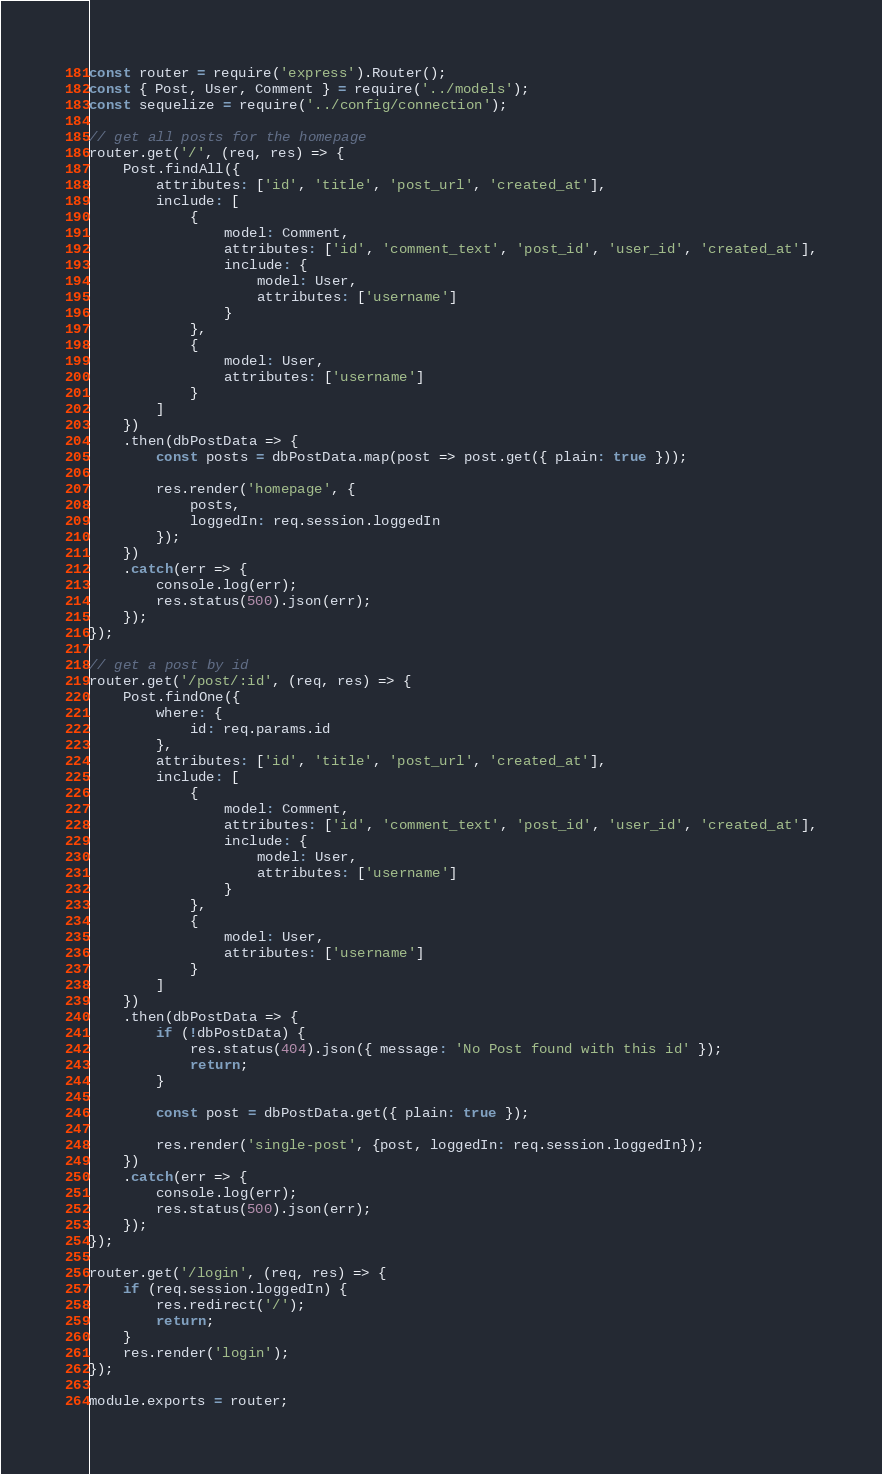<code> <loc_0><loc_0><loc_500><loc_500><_JavaScript_>const router = require('express').Router();
const { Post, User, Comment } = require('../models');
const sequelize = require('../config/connection');

// get all posts for the homepage
router.get('/', (req, res) => {
    Post.findAll({
        attributes: ['id', 'title', 'post_url', 'created_at'],
        include: [
            {
                model: Comment,
                attributes: ['id', 'comment_text', 'post_id', 'user_id', 'created_at'],
                include: {
                    model: User,
                    attributes: ['username']
                }
            },
            {
                model: User,
                attributes: ['username']
            }
        ]
    })
    .then(dbPostData => {
        const posts = dbPostData.map(post => post.get({ plain: true }));

        res.render('homepage', {
            posts,
            loggedIn: req.session.loggedIn
        });
    })
    .catch(err => {
        console.log(err);
        res.status(500).json(err);
    });
});

// get a post by id
router.get('/post/:id', (req, res) => {
    Post.findOne({
        where: {
            id: req.params.id
        },
        attributes: ['id', 'title', 'post_url', 'created_at'],
        include: [
            {
                model: Comment,
                attributes: ['id', 'comment_text', 'post_id', 'user_id', 'created_at'],
                include: {
                    model: User,
                    attributes: ['username']
                }
            },
            {
                model: User,
                attributes: ['username']
            }
        ]
    })
    .then(dbPostData => {
        if (!dbPostData) {
            res.status(404).json({ message: 'No Post found with this id' });
            return;
        }

        const post = dbPostData.get({ plain: true });

        res.render('single-post', {post, loggedIn: req.session.loggedIn});
    })
    .catch(err => {
        console.log(err);
        res.status(500).json(err);
    });
});

router.get('/login', (req, res) => {
    if (req.session.loggedIn) {
        res.redirect('/');
        return;
    }
    res.render('login');
});

module.exports = router;</code> 